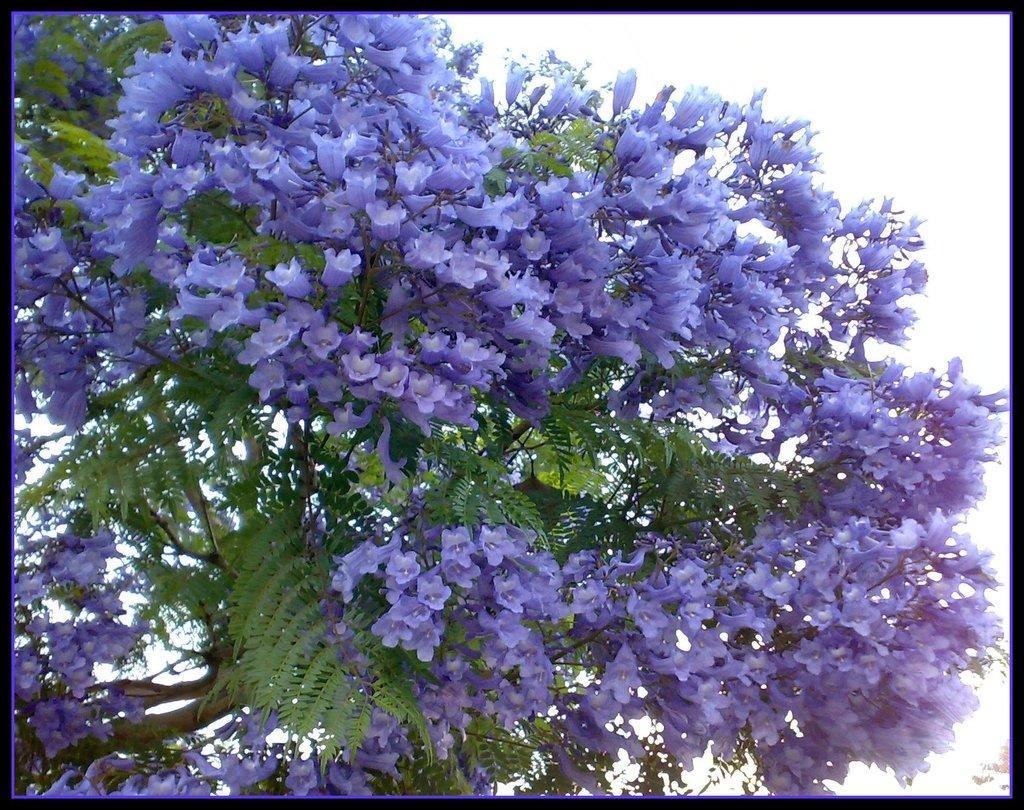In one or two sentences, can you explain what this image depicts? In this image I can see a tree with leaves and violet colour flowers. 